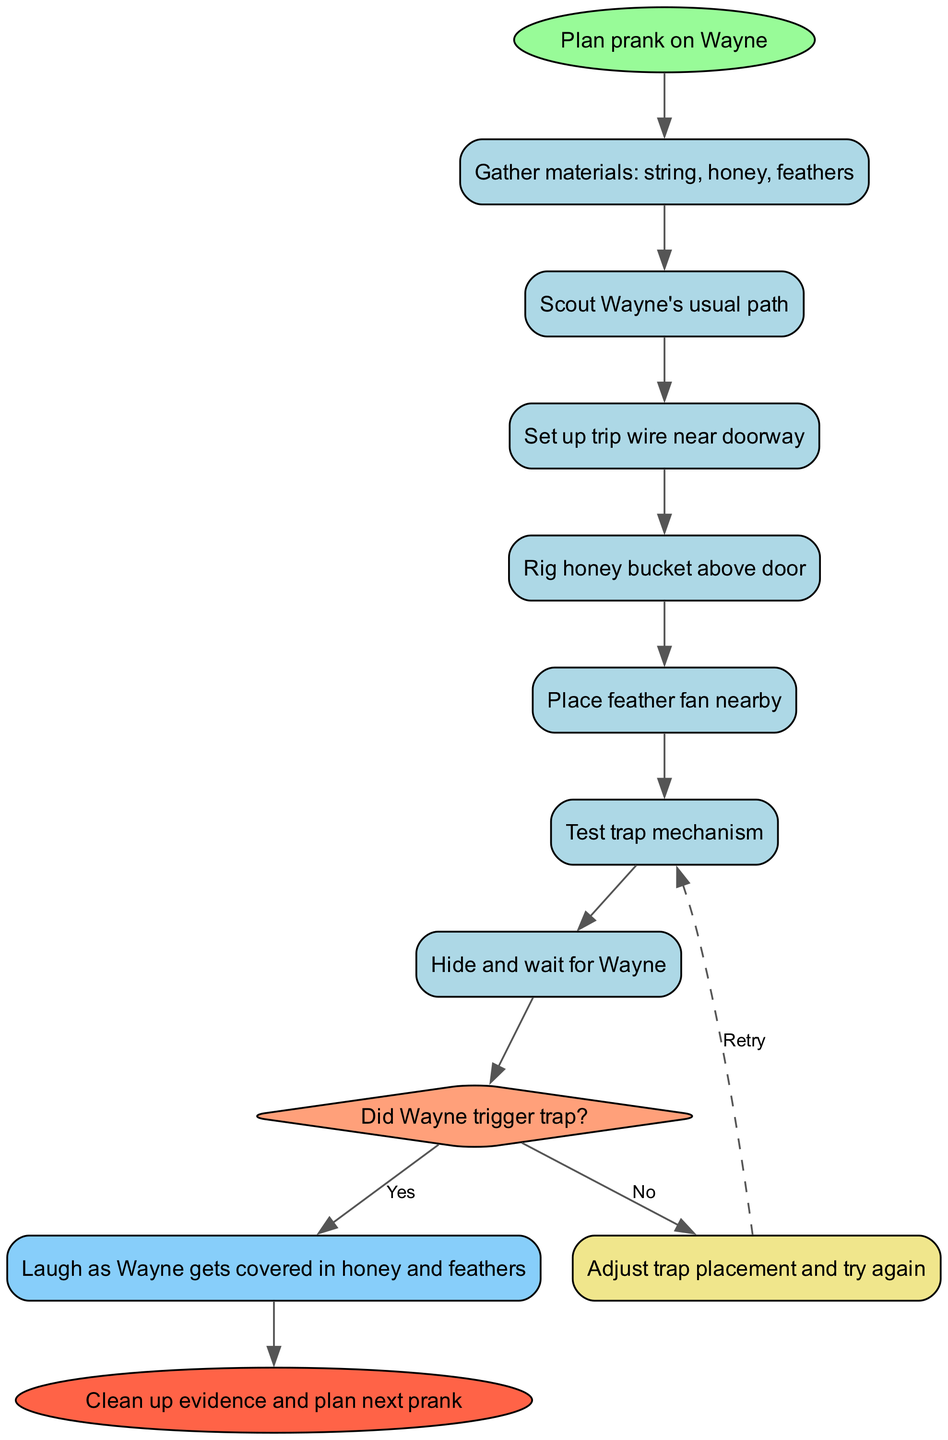What is the starting point of the process? The starting point is specified in the "start" node of the diagram, which indicates the initial action to take. According to the diagram, the starting point is "Plan prank on Wayne."
Answer: Plan prank on Wayne How many steps are there in the process? The number of steps is counted based on the entries listed under "steps" in the diagram. There are seven distinct steps outlined that indicate actions to be taken before the decision point.
Answer: 7 What is the decision point in the flowchart? The decision point is indicated in the diagram where a choice must be made based on an outcome. In this case, it is represented by "Did Wayne trigger trap?"
Answer: Did Wayne trigger trap? What happens if Wayne triggers the trap? This is an outcome related to the decision made after the trap is triggered. If Wayne triggers the trap, the corresponding outcome node says, "Laugh as Wayne gets covered in honey and feathers."
Answer: Laugh as Wayne gets covered in honey and feathers What is the last action before the end of the process? The last action is determined by going through the steps and decision outcomes leading to the conclusion of the process. After the "yes" outcome, the final action is "Clean up evidence and plan next prank."
Answer: Clean up evidence and plan next prank How many outcome nodes are present in the flowchart? The outcome nodes are identified by the results from the decision point, which yield two potential outcomes: 'yes' and 'no'. Therefore, there are two outcome nodes in total.
Answer: 2 What is the first action to undertake in the step-by-step process? The first action is defined in the first entry under "steps," which states what should be done at this initial stage of the prank process. It is "Gather materials: string, honey, feathers."
Answer: Gather materials: string, honey, feathers If Wayne does not trigger the trap, what is the next step? The "no" outcome indicates what to do if Wayne does not trigger the trap. The outcome states to "Adjust trap placement and try again," which is the instruction following the negative decision.
Answer: Adjust trap placement and try again Which shape represents the decision point in this flowchart? The diagram uses shapes to represent different types of nodes; the decision point is visually represented by a diamond shape, which conventionally indicates a choice that needs to be made.
Answer: Diamond 